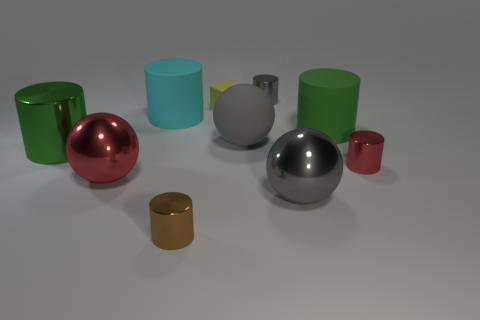Subtract all large rubber spheres. How many spheres are left? 2 Subtract all cylinders. How many objects are left? 4 Subtract all gray cylinders. How many cylinders are left? 5 Add 5 large metal spheres. How many large metal spheres are left? 7 Add 2 big green cylinders. How many big green cylinders exist? 4 Subtract 1 gray balls. How many objects are left? 9 Subtract 5 cylinders. How many cylinders are left? 1 Subtract all yellow spheres. Subtract all gray blocks. How many spheres are left? 3 Subtract all green balls. How many red blocks are left? 0 Subtract all large brown metallic blocks. Subtract all big red shiny things. How many objects are left? 9 